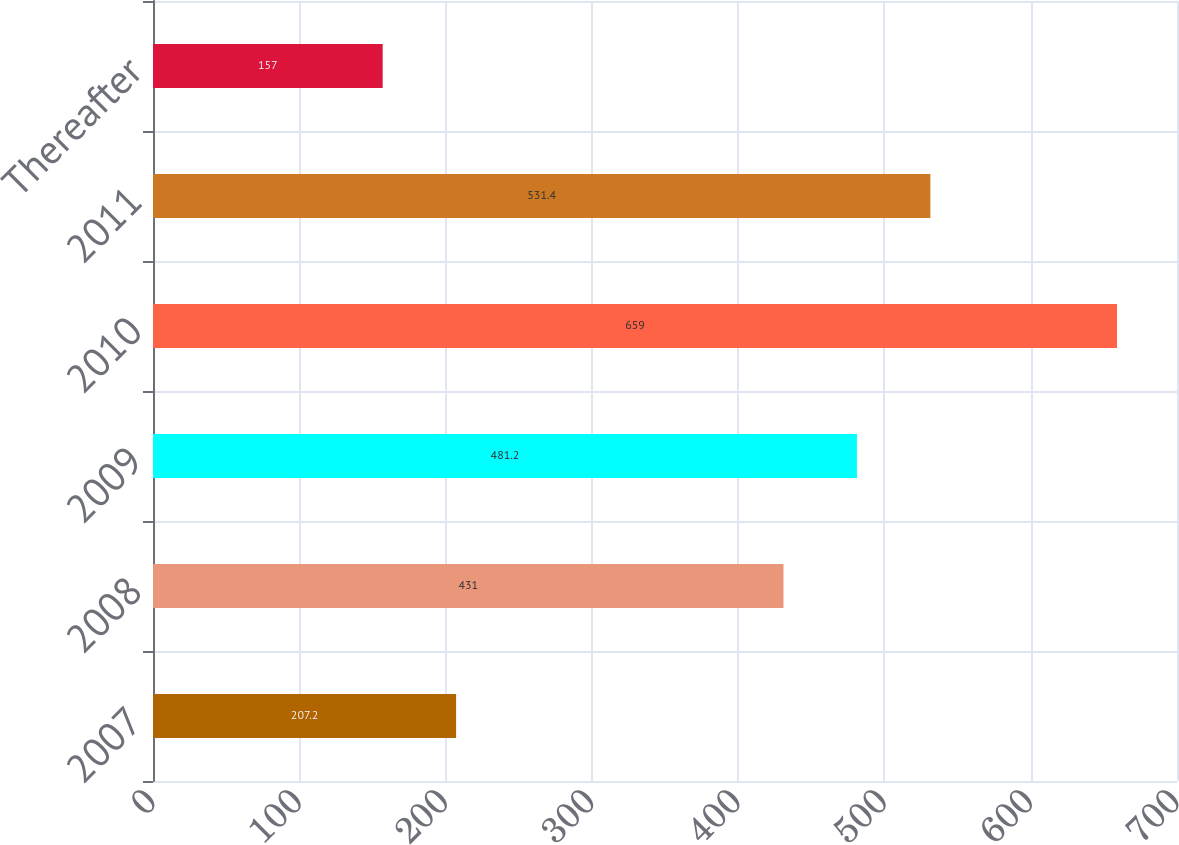Convert chart to OTSL. <chart><loc_0><loc_0><loc_500><loc_500><bar_chart><fcel>2007<fcel>2008<fcel>2009<fcel>2010<fcel>2011<fcel>Thereafter<nl><fcel>207.2<fcel>431<fcel>481.2<fcel>659<fcel>531.4<fcel>157<nl></chart> 